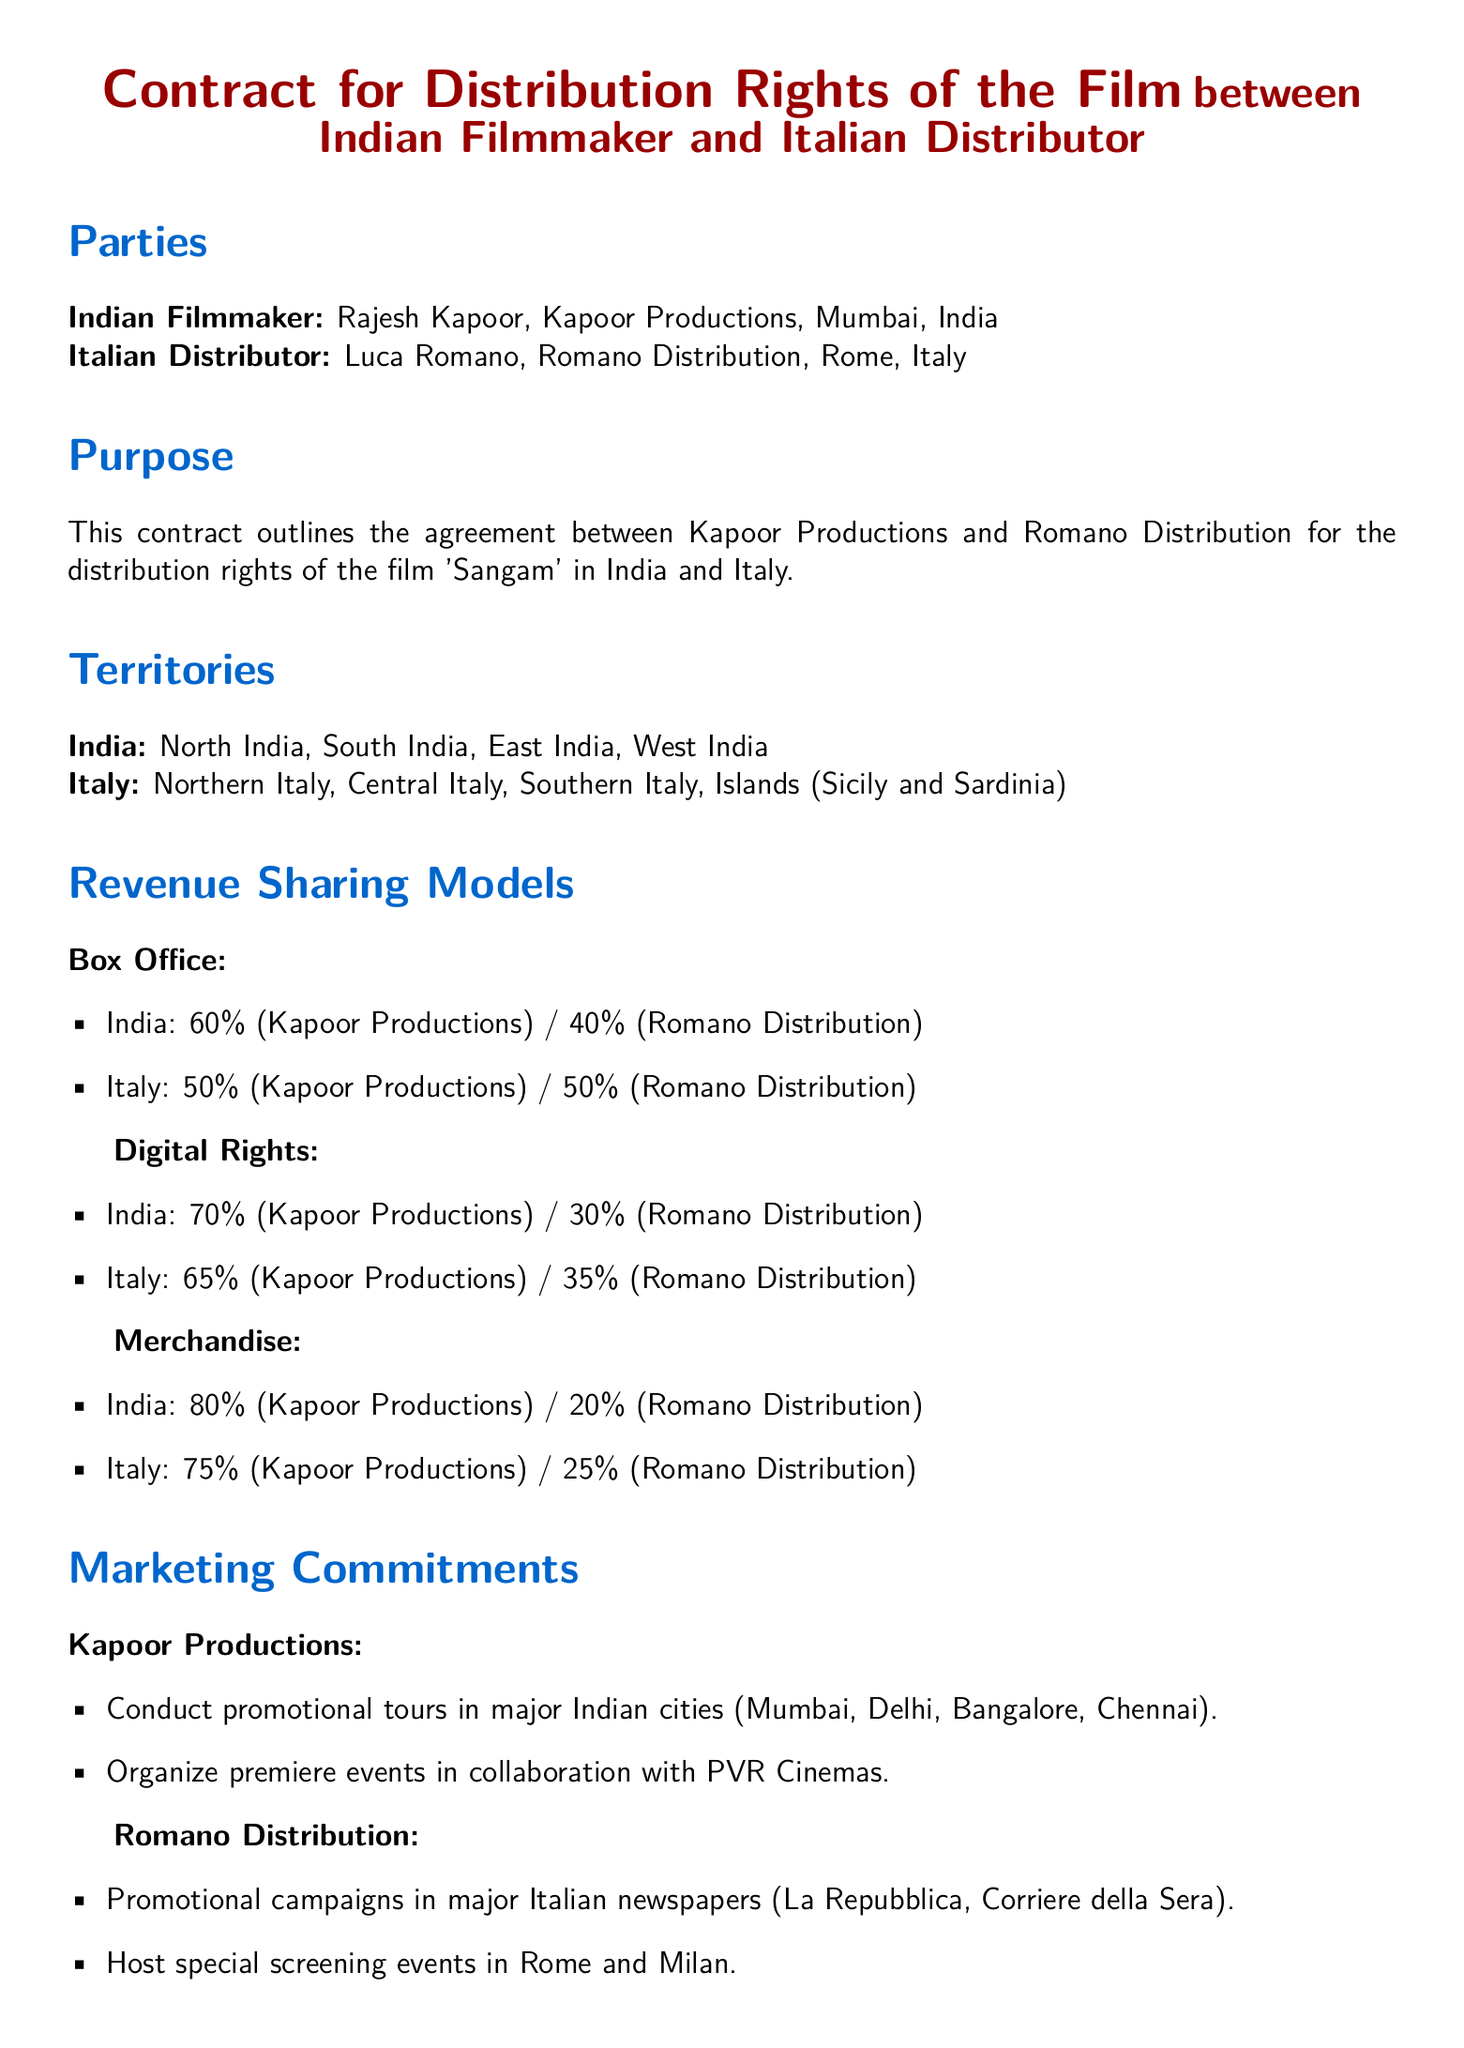What is the name of the film? The film's name is specified in the document under the purpose section.
Answer: Sangam Who are the parties involved in this contract? The document lists the names of both parties in the Parties section.
Answer: Rajesh Kapoor and Luca Romano What is the revenue share for box office in Italy? The box office revenue share for Italy is specified in the Revenue Sharing Models section.
Answer: 50% (Kapoor Productions) / 50% (Romano Distribution) What territories are specified for distribution in India? The document lists multiple regions in the Territories section.
Answer: North India, South India, East India, West India What marketing commitments does Kapoor Productions have? The document details the specific marketing actions Kapoor Productions will undertake.
Answer: Conduct promotional tours, Organize premiere events What is the initial term of this contract? The length of the contract's initial term is mentioned in the Term section of the document.
Answer: 5 years What percentage of merchandise revenue does Kapoor Productions receive in Italy? The merchandise revenue share for Italy is detailed in the Revenue Sharing Models section.
Answer: 75% (Kapoor Productions) / 25% (Romano Distribution) Where will special screening events be hosted by Romano Distribution? The document specifies the locations for these events in the Marketing Commitments section.
Answer: Rome and Milan Is there an option to renew the contract? The document states the terms regarding the renewal of the contract under the Term section.
Answer: Yes 